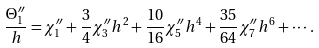<formula> <loc_0><loc_0><loc_500><loc_500>\frac { \Theta _ { 1 } ^ { \prime \prime } } { h } = \chi _ { 1 } ^ { \prime \prime } + \frac { 3 } { 4 } \chi _ { 3 } ^ { \prime \prime } h ^ { 2 } + \frac { 1 0 } { 1 6 } \chi _ { 5 } ^ { \prime \prime } h ^ { 4 } + \frac { 3 5 } { 6 4 } \chi _ { 7 } ^ { \prime \prime } h ^ { 6 } + \cdots .</formula> 